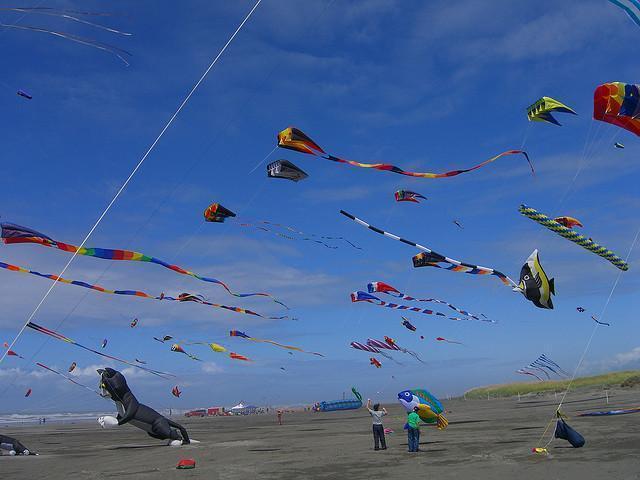How many kites are in the picture?
Give a very brief answer. 5. 